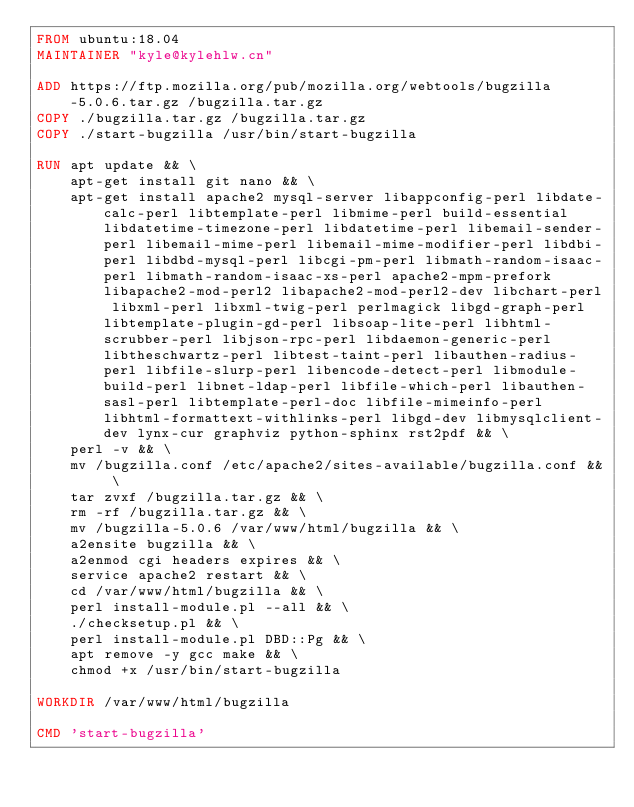<code> <loc_0><loc_0><loc_500><loc_500><_Dockerfile_>FROM ubuntu:18.04
MAINTAINER "kyle@kylehlw.cn"

ADD https://ftp.mozilla.org/pub/mozilla.org/webtools/bugzilla-5.0.6.tar.gz /bugzilla.tar.gz
COPY ./bugzilla.tar.gz /bugzilla.tar.gz
COPY ./start-bugzilla /usr/bin/start-bugzilla

RUN apt update && \
    apt-get install git nano && \
    apt-get install apache2 mysql-server libappconfig-perl libdate-calc-perl libtemplate-perl libmime-perl build-essential libdatetime-timezone-perl libdatetime-perl libemail-sender-perl libemail-mime-perl libemail-mime-modifier-perl libdbi-perl libdbd-mysql-perl libcgi-pm-perl libmath-random-isaac-perl libmath-random-isaac-xs-perl apache2-mpm-prefork libapache2-mod-perl2 libapache2-mod-perl2-dev libchart-perl libxml-perl libxml-twig-perl perlmagick libgd-graph-perl libtemplate-plugin-gd-perl libsoap-lite-perl libhtml-scrubber-perl libjson-rpc-perl libdaemon-generic-perl libtheschwartz-perl libtest-taint-perl libauthen-radius-perl libfile-slurp-perl libencode-detect-perl libmodule-build-perl libnet-ldap-perl libfile-which-perl libauthen-sasl-perl libtemplate-perl-doc libfile-mimeinfo-perl libhtml-formattext-withlinks-perl libgd-dev libmysqlclient-dev lynx-cur graphviz python-sphinx rst2pdf && \
    perl -v && \
    mv /bugzilla.conf /etc/apache2/sites-available/bugzilla.conf && \
    tar zvxf /bugzilla.tar.gz && \
    rm -rf /bugzilla.tar.gz && \
    mv /bugzilla-5.0.6 /var/www/html/bugzilla && \
    a2ensite bugzilla && \
    a2enmod cgi headers expires && \
    service apache2 restart && \
    cd /var/www/html/bugzilla && \
    perl install-module.pl --all && \
    ./checksetup.pl && \
    perl install-module.pl DBD::Pg && \
    apt remove -y gcc make && \
    chmod +x /usr/bin/start-bugzilla

WORKDIR /var/www/html/bugzilla

CMD 'start-bugzilla'
</code> 